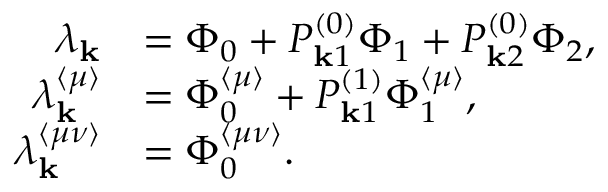<formula> <loc_0><loc_0><loc_500><loc_500>\begin{array} { r l } { \lambda _ { k } } & { = \Phi _ { 0 } + P _ { k 1 } ^ { ( 0 ) } \Phi _ { 1 } + P _ { k 2 } ^ { ( 0 ) } \Phi _ { 2 } , } \\ { \lambda _ { k } ^ { \langle \mu \rangle } } & { = \Phi _ { 0 } ^ { \langle \mu \rangle } + P _ { k 1 } ^ { ( 1 ) } \Phi _ { 1 } ^ { \langle \mu \rangle } , } \\ { \lambda _ { k } ^ { \langle \mu \nu \rangle } } & { = \Phi _ { 0 } ^ { \langle \mu \nu \rangle } . } \end{array}</formula> 